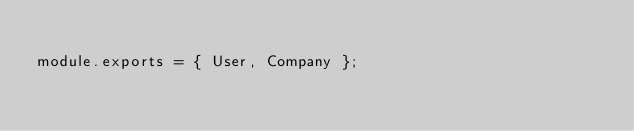<code> <loc_0><loc_0><loc_500><loc_500><_JavaScript_>
module.exports = { User, Company };</code> 